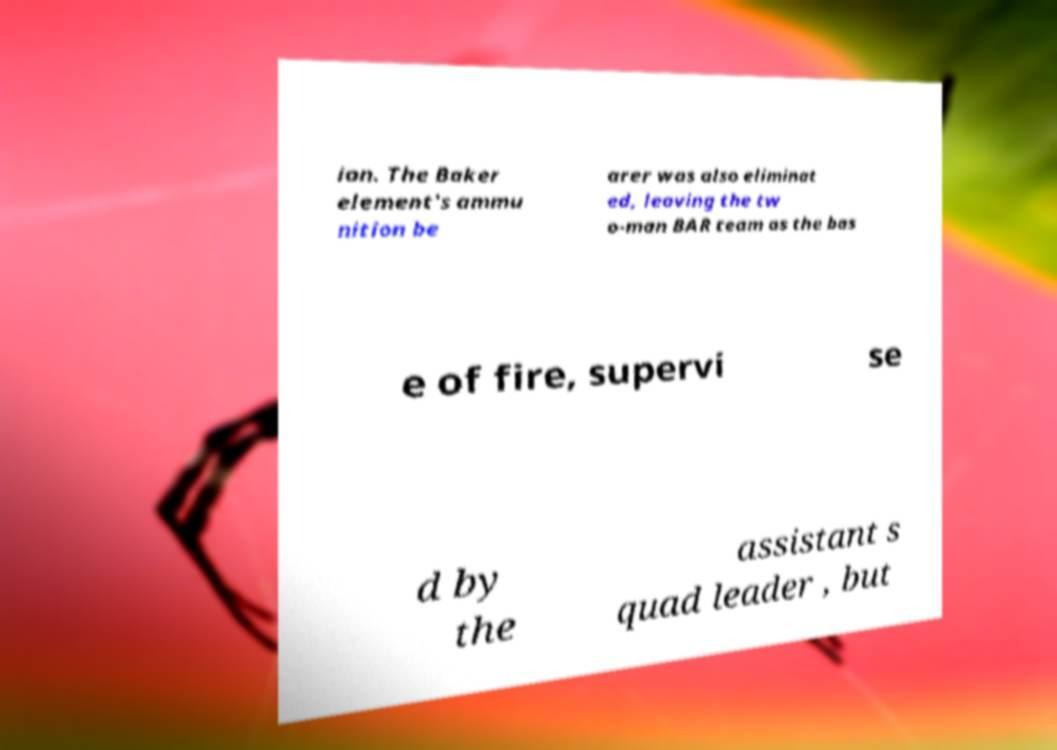Please identify and transcribe the text found in this image. ion. The Baker element's ammu nition be arer was also eliminat ed, leaving the tw o-man BAR team as the bas e of fire, supervi se d by the assistant s quad leader , but 